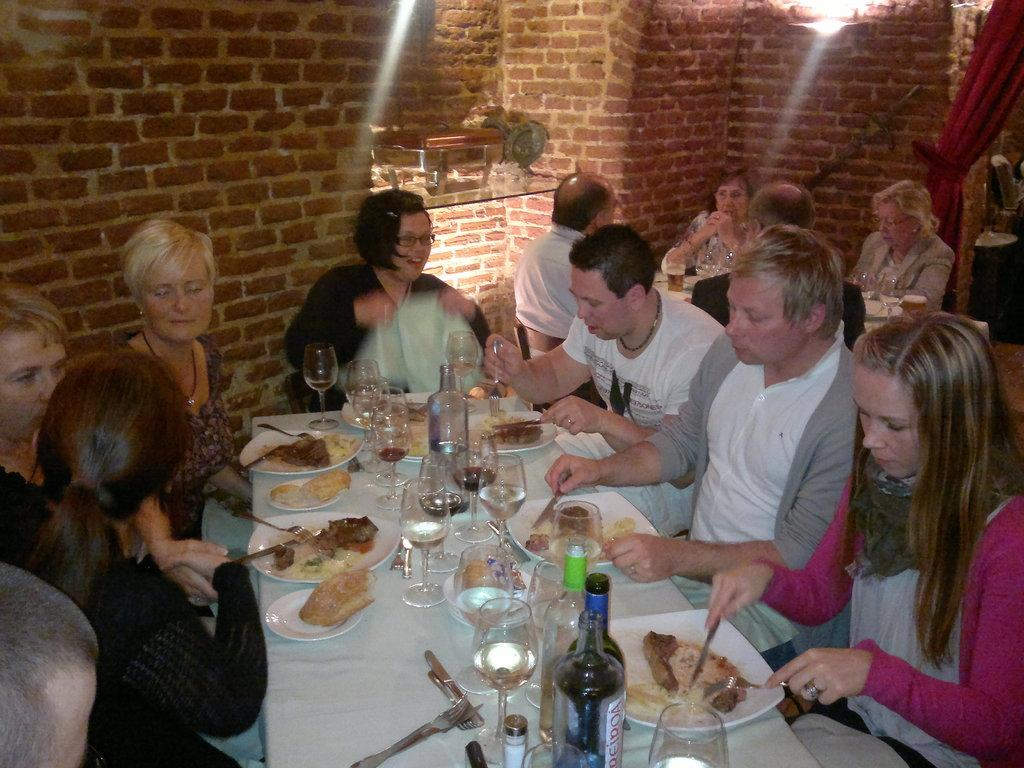What are the people in the image doing? The people in the image are sitting on chairs. What can be seen on the table in the image? There are wine glasses and wine bottles on the table. What type of food is present on a plate in the image? There are food items on a plate in the image. What type of engine is visible in the image? There is no engine present in the image. What historical event is being commemorated in the image? There is no indication of a historical event being commemorated in the image. 